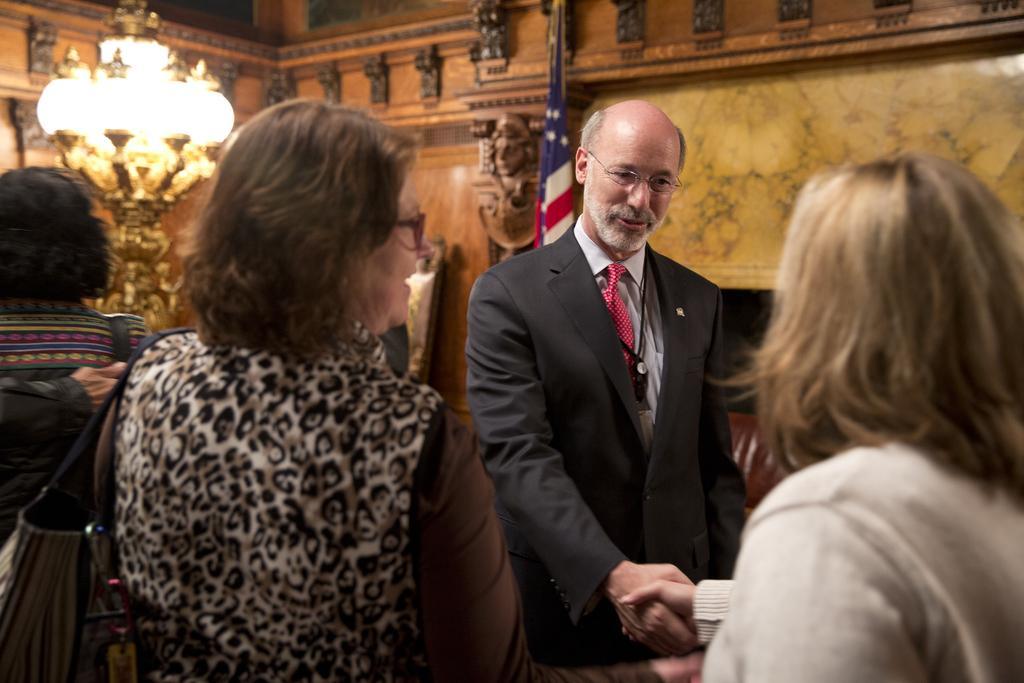Can you describe this image briefly? In this image there are four persons standing , two persons handshaking each other , and in the background there is a chandelier, flag and wall. 